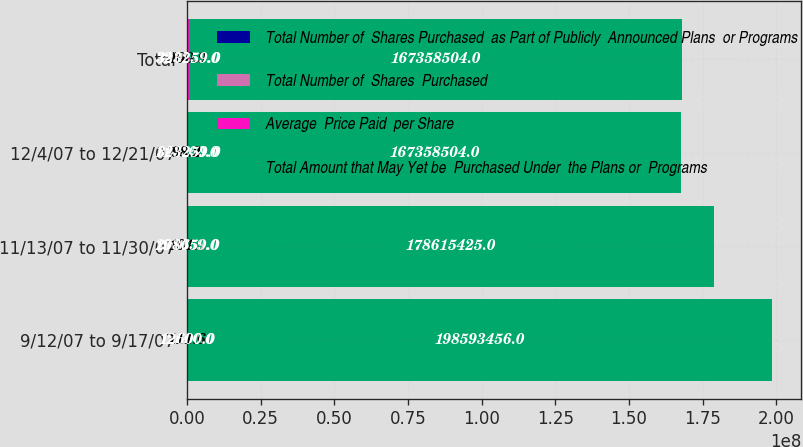Convert chart to OTSL. <chart><loc_0><loc_0><loc_500><loc_500><stacked_bar_chart><ecel><fcel>9/12/07 to 9/17/07<fcel>11/13/07 to 11/30/07<fcel>12/4/07 to 12/21/07<fcel>Total<nl><fcel>Total Number of  Shares Purchased  as Part of Publicly  Announced Plans  or Programs<fcel>12600<fcel>196059<fcel>114600<fcel>323259<nl><fcel>Total Number of  Shares  Purchased<fcel>111.6<fcel>101.9<fcel>98.2<fcel>100.9<nl><fcel>Average  Price Paid  per Share<fcel>12600<fcel>208659<fcel>323259<fcel>323259<nl><fcel>Total Amount that May Yet be  Purchased Under  the Plans or  Programs<fcel>1.98593e+08<fcel>1.78615e+08<fcel>1.67359e+08<fcel>1.67359e+08<nl></chart> 